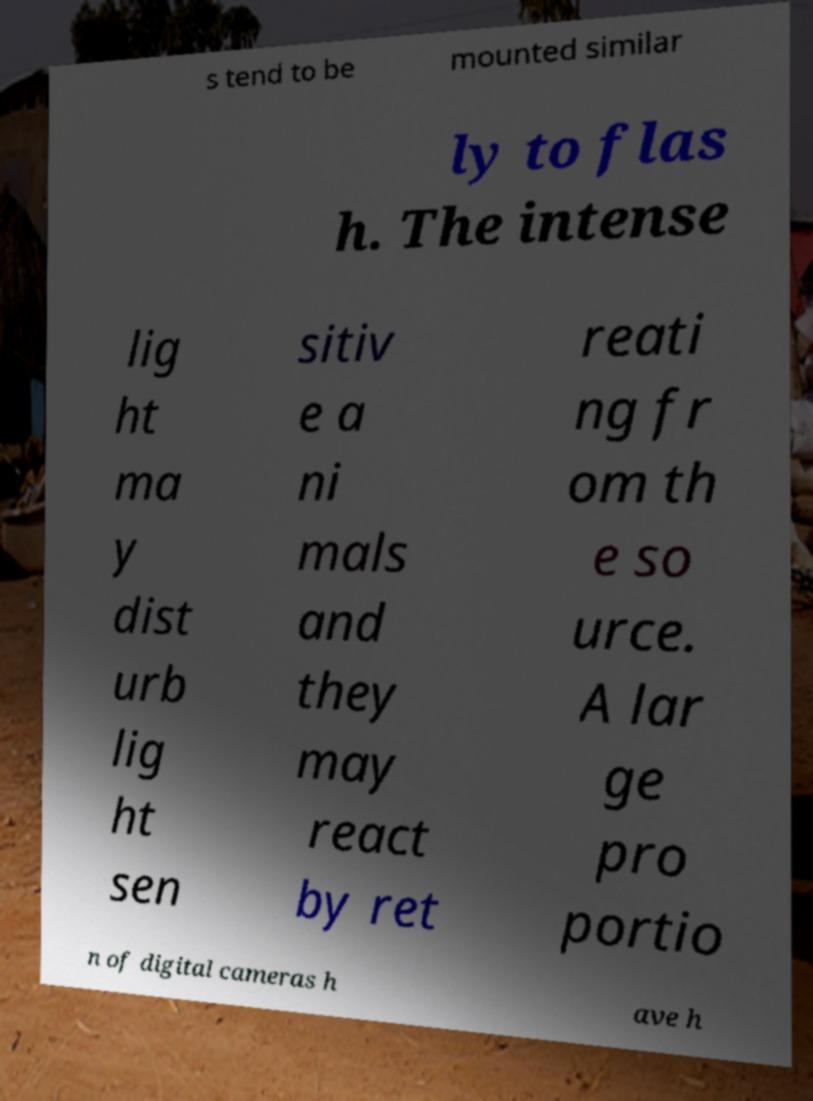Please identify and transcribe the text found in this image. s tend to be mounted similar ly to flas h. The intense lig ht ma y dist urb lig ht sen sitiv e a ni mals and they may react by ret reati ng fr om th e so urce. A lar ge pro portio n of digital cameras h ave h 